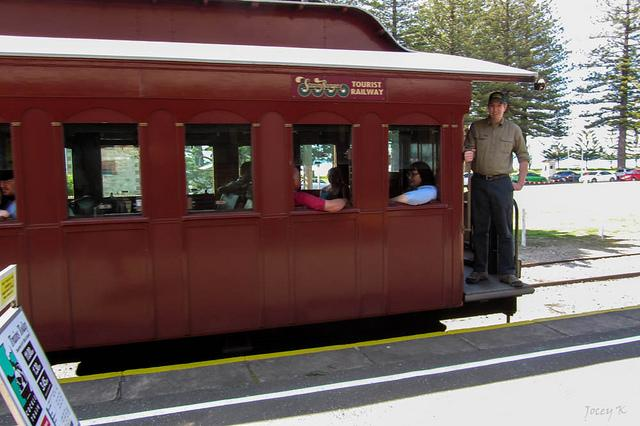What type passengers board this train? Please explain your reasoning. tourists. The passengers who commonly board this train are tourists. 